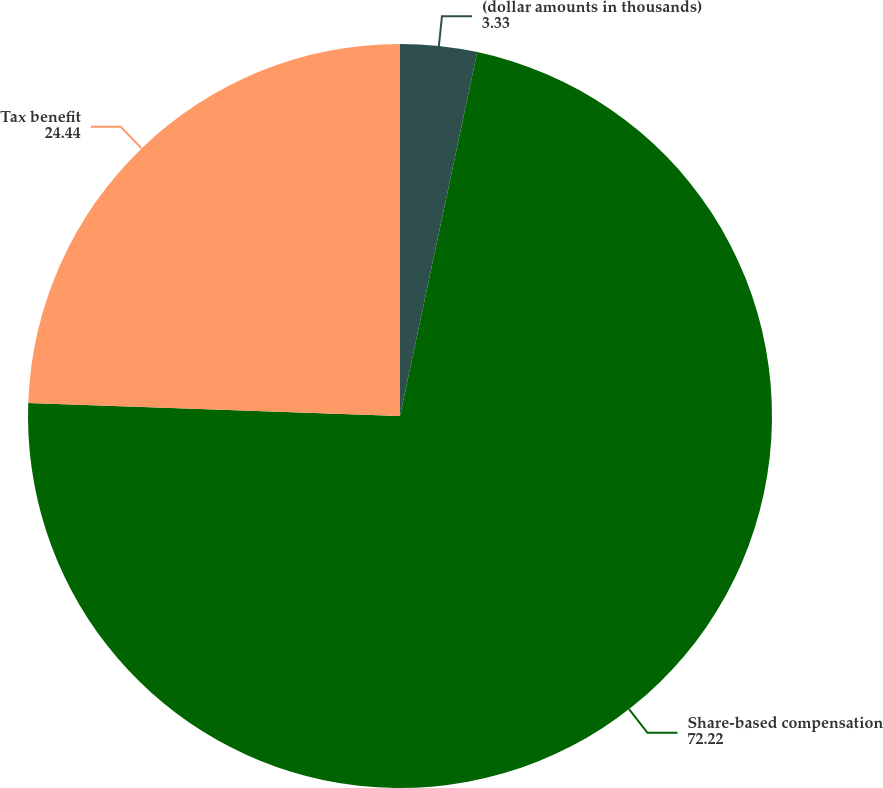<chart> <loc_0><loc_0><loc_500><loc_500><pie_chart><fcel>(dollar amounts in thousands)<fcel>Share-based compensation<fcel>Tax benefit<nl><fcel>3.33%<fcel>72.22%<fcel>24.44%<nl></chart> 